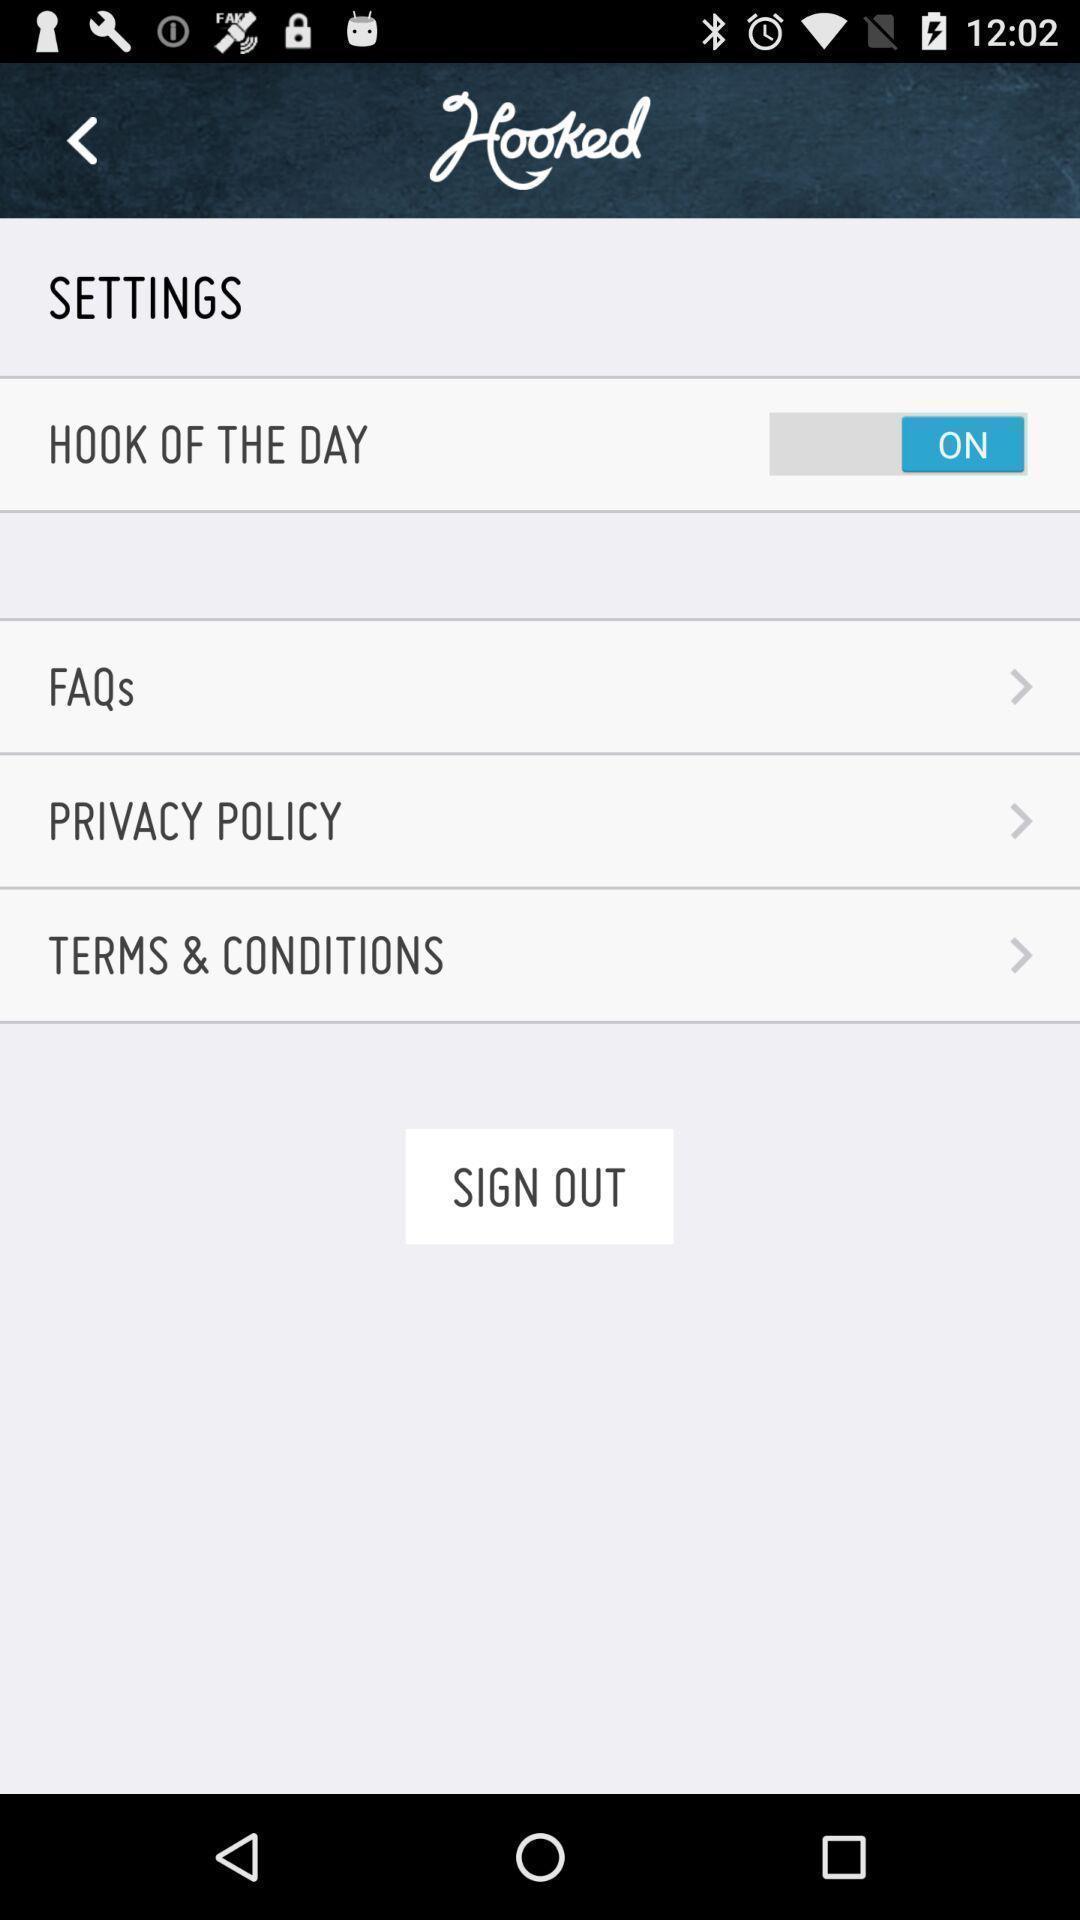What is the overall content of this screenshot? Settings page of food and drink application. 